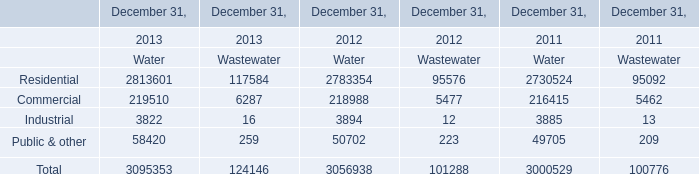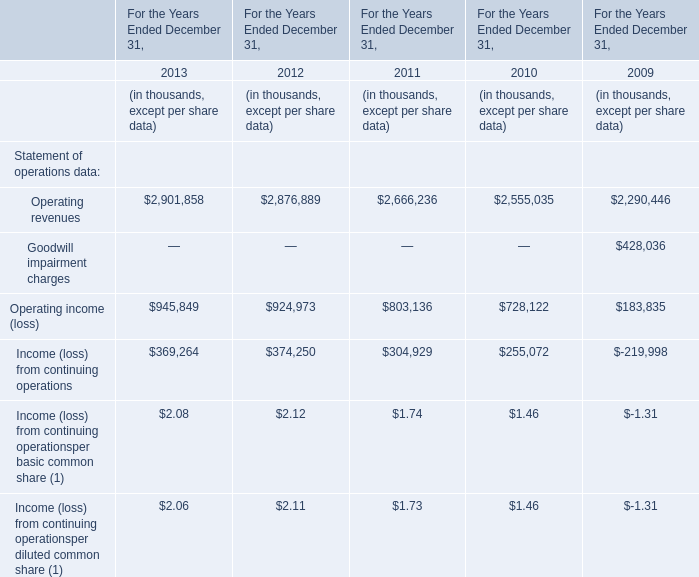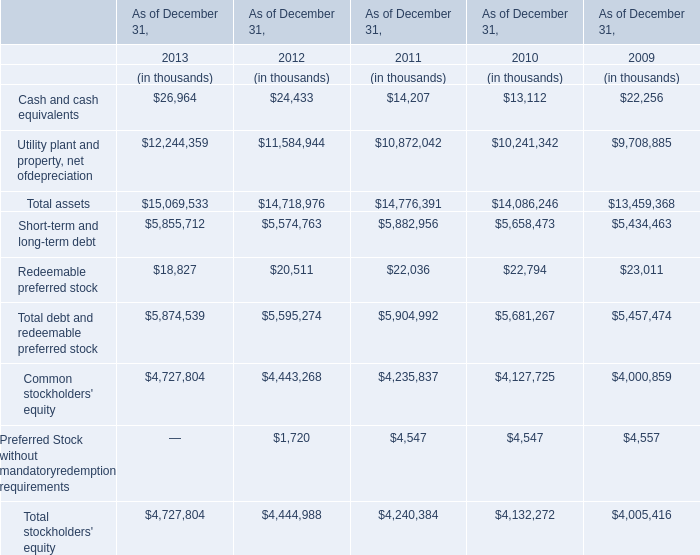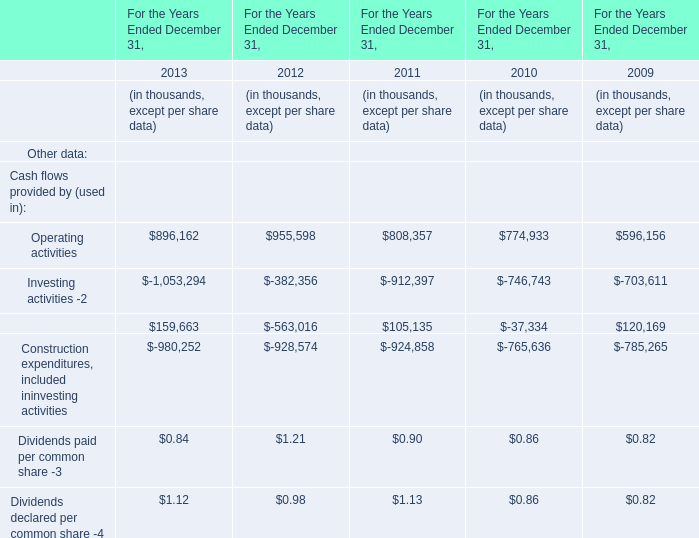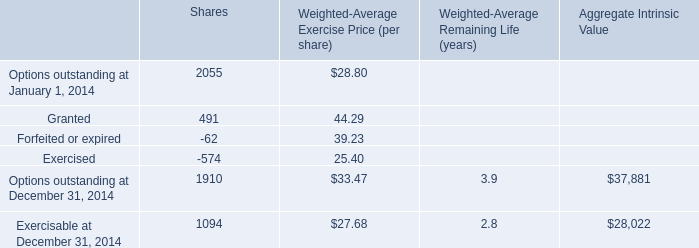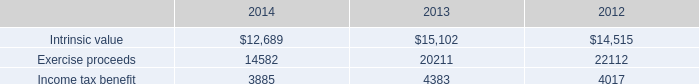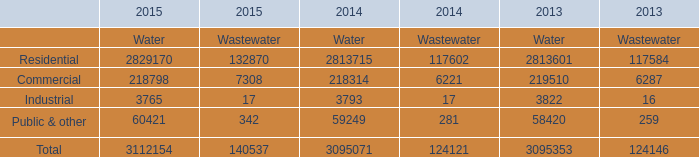What is the sum of Commercial of December 31, 2013 Wastewater, Residential of 2014 Water, and Industrial of 2013 Water ? 
Computations: ((6287.0 + 2813715.0) + 3822.0)
Answer: 2823824.0. 